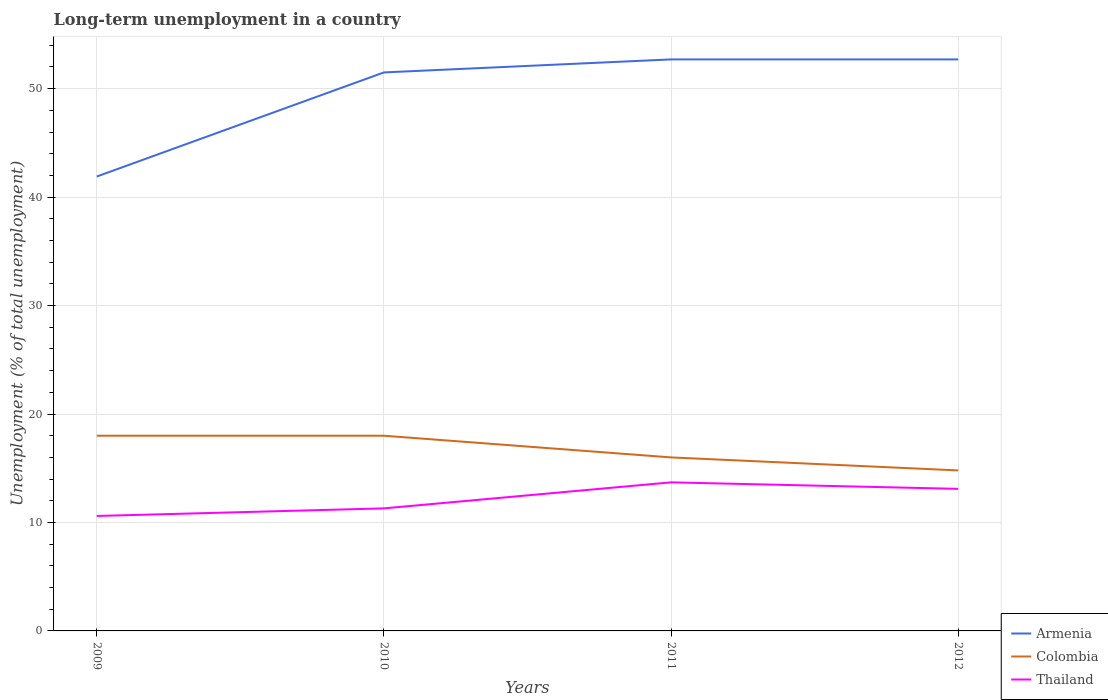Across all years, what is the maximum percentage of long-term unemployed population in Colombia?
Offer a terse response. 14.8. What is the total percentage of long-term unemployed population in Armenia in the graph?
Keep it short and to the point. -10.8. What is the difference between the highest and the second highest percentage of long-term unemployed population in Thailand?
Your answer should be compact. 3.1. Is the percentage of long-term unemployed population in Armenia strictly greater than the percentage of long-term unemployed population in Colombia over the years?
Keep it short and to the point. No. Does the graph contain grids?
Offer a terse response. Yes. How many legend labels are there?
Your answer should be very brief. 3. How are the legend labels stacked?
Ensure brevity in your answer.  Vertical. What is the title of the graph?
Give a very brief answer. Long-term unemployment in a country. Does "Belgium" appear as one of the legend labels in the graph?
Ensure brevity in your answer.  No. What is the label or title of the X-axis?
Your answer should be compact. Years. What is the label or title of the Y-axis?
Provide a succinct answer. Unemployment (% of total unemployment). What is the Unemployment (% of total unemployment) of Armenia in 2009?
Keep it short and to the point. 41.9. What is the Unemployment (% of total unemployment) of Colombia in 2009?
Your response must be concise. 18. What is the Unemployment (% of total unemployment) of Thailand in 2009?
Your response must be concise. 10.6. What is the Unemployment (% of total unemployment) of Armenia in 2010?
Your answer should be compact. 51.5. What is the Unemployment (% of total unemployment) of Thailand in 2010?
Give a very brief answer. 11.3. What is the Unemployment (% of total unemployment) in Armenia in 2011?
Offer a very short reply. 52.7. What is the Unemployment (% of total unemployment) in Colombia in 2011?
Your answer should be very brief. 16. What is the Unemployment (% of total unemployment) of Thailand in 2011?
Keep it short and to the point. 13.7. What is the Unemployment (% of total unemployment) of Armenia in 2012?
Your answer should be compact. 52.7. What is the Unemployment (% of total unemployment) of Colombia in 2012?
Give a very brief answer. 14.8. What is the Unemployment (% of total unemployment) of Thailand in 2012?
Give a very brief answer. 13.1. Across all years, what is the maximum Unemployment (% of total unemployment) of Armenia?
Provide a succinct answer. 52.7. Across all years, what is the maximum Unemployment (% of total unemployment) of Thailand?
Your answer should be compact. 13.7. Across all years, what is the minimum Unemployment (% of total unemployment) in Armenia?
Your answer should be compact. 41.9. Across all years, what is the minimum Unemployment (% of total unemployment) in Colombia?
Provide a succinct answer. 14.8. Across all years, what is the minimum Unemployment (% of total unemployment) in Thailand?
Keep it short and to the point. 10.6. What is the total Unemployment (% of total unemployment) in Armenia in the graph?
Make the answer very short. 198.8. What is the total Unemployment (% of total unemployment) of Colombia in the graph?
Your response must be concise. 66.8. What is the total Unemployment (% of total unemployment) in Thailand in the graph?
Offer a terse response. 48.7. What is the difference between the Unemployment (% of total unemployment) of Thailand in 2009 and that in 2010?
Your answer should be very brief. -0.7. What is the difference between the Unemployment (% of total unemployment) in Colombia in 2009 and that in 2011?
Give a very brief answer. 2. What is the difference between the Unemployment (% of total unemployment) in Thailand in 2009 and that in 2011?
Keep it short and to the point. -3.1. What is the difference between the Unemployment (% of total unemployment) in Armenia in 2009 and that in 2012?
Make the answer very short. -10.8. What is the difference between the Unemployment (% of total unemployment) of Colombia in 2009 and that in 2012?
Provide a short and direct response. 3.2. What is the difference between the Unemployment (% of total unemployment) in Thailand in 2009 and that in 2012?
Your answer should be very brief. -2.5. What is the difference between the Unemployment (% of total unemployment) of Armenia in 2010 and that in 2011?
Give a very brief answer. -1.2. What is the difference between the Unemployment (% of total unemployment) in Thailand in 2010 and that in 2011?
Your answer should be compact. -2.4. What is the difference between the Unemployment (% of total unemployment) in Armenia in 2010 and that in 2012?
Offer a very short reply. -1.2. What is the difference between the Unemployment (% of total unemployment) of Colombia in 2010 and that in 2012?
Keep it short and to the point. 3.2. What is the difference between the Unemployment (% of total unemployment) of Thailand in 2010 and that in 2012?
Keep it short and to the point. -1.8. What is the difference between the Unemployment (% of total unemployment) of Armenia in 2011 and that in 2012?
Offer a terse response. 0. What is the difference between the Unemployment (% of total unemployment) of Colombia in 2011 and that in 2012?
Offer a terse response. 1.2. What is the difference between the Unemployment (% of total unemployment) of Armenia in 2009 and the Unemployment (% of total unemployment) of Colombia in 2010?
Provide a succinct answer. 23.9. What is the difference between the Unemployment (% of total unemployment) in Armenia in 2009 and the Unemployment (% of total unemployment) in Thailand in 2010?
Provide a succinct answer. 30.6. What is the difference between the Unemployment (% of total unemployment) in Colombia in 2009 and the Unemployment (% of total unemployment) in Thailand in 2010?
Offer a very short reply. 6.7. What is the difference between the Unemployment (% of total unemployment) in Armenia in 2009 and the Unemployment (% of total unemployment) in Colombia in 2011?
Make the answer very short. 25.9. What is the difference between the Unemployment (% of total unemployment) of Armenia in 2009 and the Unemployment (% of total unemployment) of Thailand in 2011?
Give a very brief answer. 28.2. What is the difference between the Unemployment (% of total unemployment) in Colombia in 2009 and the Unemployment (% of total unemployment) in Thailand in 2011?
Offer a terse response. 4.3. What is the difference between the Unemployment (% of total unemployment) of Armenia in 2009 and the Unemployment (% of total unemployment) of Colombia in 2012?
Your answer should be very brief. 27.1. What is the difference between the Unemployment (% of total unemployment) in Armenia in 2009 and the Unemployment (% of total unemployment) in Thailand in 2012?
Provide a short and direct response. 28.8. What is the difference between the Unemployment (% of total unemployment) of Colombia in 2009 and the Unemployment (% of total unemployment) of Thailand in 2012?
Your answer should be compact. 4.9. What is the difference between the Unemployment (% of total unemployment) of Armenia in 2010 and the Unemployment (% of total unemployment) of Colombia in 2011?
Ensure brevity in your answer.  35.5. What is the difference between the Unemployment (% of total unemployment) in Armenia in 2010 and the Unemployment (% of total unemployment) in Thailand in 2011?
Offer a very short reply. 37.8. What is the difference between the Unemployment (% of total unemployment) of Armenia in 2010 and the Unemployment (% of total unemployment) of Colombia in 2012?
Your answer should be compact. 36.7. What is the difference between the Unemployment (% of total unemployment) in Armenia in 2010 and the Unemployment (% of total unemployment) in Thailand in 2012?
Offer a terse response. 38.4. What is the difference between the Unemployment (% of total unemployment) of Armenia in 2011 and the Unemployment (% of total unemployment) of Colombia in 2012?
Your response must be concise. 37.9. What is the difference between the Unemployment (% of total unemployment) of Armenia in 2011 and the Unemployment (% of total unemployment) of Thailand in 2012?
Keep it short and to the point. 39.6. What is the difference between the Unemployment (% of total unemployment) of Colombia in 2011 and the Unemployment (% of total unemployment) of Thailand in 2012?
Offer a very short reply. 2.9. What is the average Unemployment (% of total unemployment) in Armenia per year?
Keep it short and to the point. 49.7. What is the average Unemployment (% of total unemployment) of Colombia per year?
Provide a succinct answer. 16.7. What is the average Unemployment (% of total unemployment) in Thailand per year?
Your response must be concise. 12.18. In the year 2009, what is the difference between the Unemployment (% of total unemployment) of Armenia and Unemployment (% of total unemployment) of Colombia?
Your answer should be compact. 23.9. In the year 2009, what is the difference between the Unemployment (% of total unemployment) in Armenia and Unemployment (% of total unemployment) in Thailand?
Offer a very short reply. 31.3. In the year 2009, what is the difference between the Unemployment (% of total unemployment) of Colombia and Unemployment (% of total unemployment) of Thailand?
Give a very brief answer. 7.4. In the year 2010, what is the difference between the Unemployment (% of total unemployment) of Armenia and Unemployment (% of total unemployment) of Colombia?
Your answer should be very brief. 33.5. In the year 2010, what is the difference between the Unemployment (% of total unemployment) of Armenia and Unemployment (% of total unemployment) of Thailand?
Your answer should be compact. 40.2. In the year 2011, what is the difference between the Unemployment (% of total unemployment) in Armenia and Unemployment (% of total unemployment) in Colombia?
Ensure brevity in your answer.  36.7. In the year 2011, what is the difference between the Unemployment (% of total unemployment) of Colombia and Unemployment (% of total unemployment) of Thailand?
Offer a terse response. 2.3. In the year 2012, what is the difference between the Unemployment (% of total unemployment) in Armenia and Unemployment (% of total unemployment) in Colombia?
Keep it short and to the point. 37.9. In the year 2012, what is the difference between the Unemployment (% of total unemployment) in Armenia and Unemployment (% of total unemployment) in Thailand?
Ensure brevity in your answer.  39.6. In the year 2012, what is the difference between the Unemployment (% of total unemployment) of Colombia and Unemployment (% of total unemployment) of Thailand?
Provide a short and direct response. 1.7. What is the ratio of the Unemployment (% of total unemployment) of Armenia in 2009 to that in 2010?
Your response must be concise. 0.81. What is the ratio of the Unemployment (% of total unemployment) in Thailand in 2009 to that in 2010?
Offer a very short reply. 0.94. What is the ratio of the Unemployment (% of total unemployment) in Armenia in 2009 to that in 2011?
Make the answer very short. 0.8. What is the ratio of the Unemployment (% of total unemployment) in Thailand in 2009 to that in 2011?
Offer a very short reply. 0.77. What is the ratio of the Unemployment (% of total unemployment) of Armenia in 2009 to that in 2012?
Offer a very short reply. 0.8. What is the ratio of the Unemployment (% of total unemployment) in Colombia in 2009 to that in 2012?
Give a very brief answer. 1.22. What is the ratio of the Unemployment (% of total unemployment) of Thailand in 2009 to that in 2012?
Your response must be concise. 0.81. What is the ratio of the Unemployment (% of total unemployment) of Armenia in 2010 to that in 2011?
Keep it short and to the point. 0.98. What is the ratio of the Unemployment (% of total unemployment) of Thailand in 2010 to that in 2011?
Provide a succinct answer. 0.82. What is the ratio of the Unemployment (% of total unemployment) in Armenia in 2010 to that in 2012?
Ensure brevity in your answer.  0.98. What is the ratio of the Unemployment (% of total unemployment) of Colombia in 2010 to that in 2012?
Provide a succinct answer. 1.22. What is the ratio of the Unemployment (% of total unemployment) of Thailand in 2010 to that in 2012?
Your answer should be very brief. 0.86. What is the ratio of the Unemployment (% of total unemployment) in Colombia in 2011 to that in 2012?
Offer a terse response. 1.08. What is the ratio of the Unemployment (% of total unemployment) in Thailand in 2011 to that in 2012?
Ensure brevity in your answer.  1.05. What is the difference between the highest and the second highest Unemployment (% of total unemployment) of Colombia?
Your response must be concise. 0. What is the difference between the highest and the second highest Unemployment (% of total unemployment) of Thailand?
Your answer should be very brief. 0.6. What is the difference between the highest and the lowest Unemployment (% of total unemployment) in Armenia?
Your answer should be very brief. 10.8. What is the difference between the highest and the lowest Unemployment (% of total unemployment) of Colombia?
Provide a short and direct response. 3.2. 